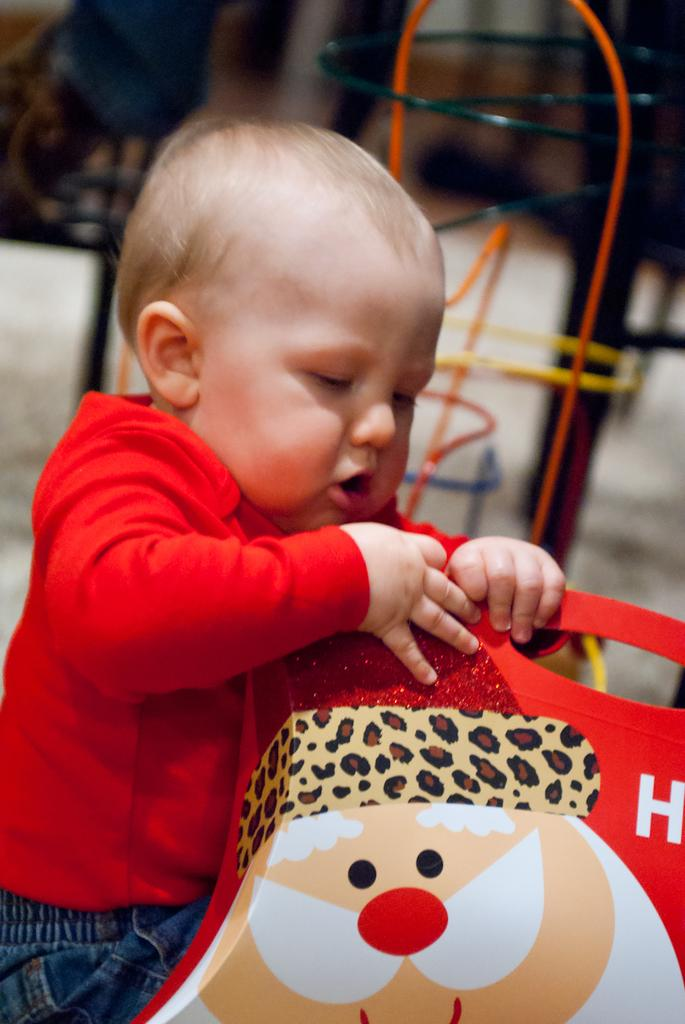What is the main subject in the foreground of the picture? There is a kid in the foreground of the picture. What is the kid wearing? The kid is wearing a red t-shirt. What is the kid doing in the picture? The kid is playing with a toy. Can you describe the background of the image? The background of the image is blurred. What else can be seen in the background of the image? There are playing things in the background of the image. What type of creature is protesting in the background of the image? There is no creature present in the image, nor is there any protest or indication of a protest in the image. 